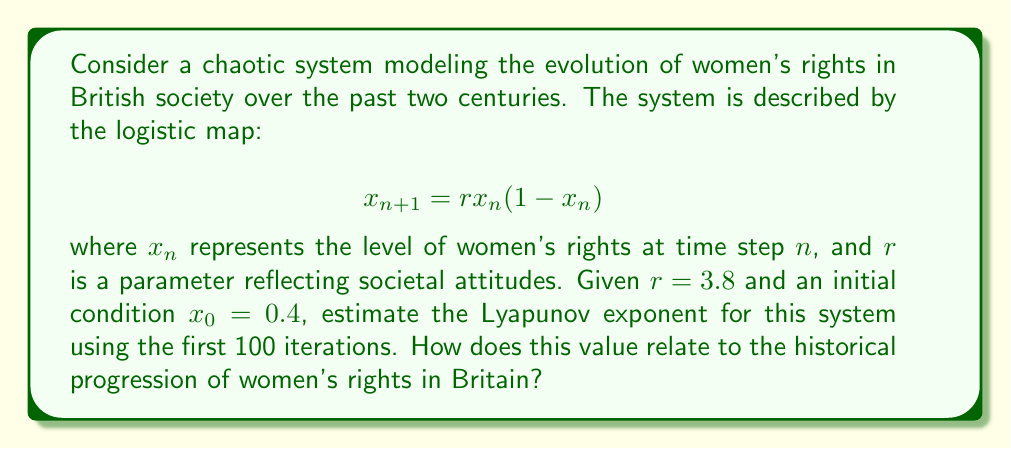Can you answer this question? To estimate the Lyapunov exponent for this system, we'll follow these steps:

1) The Lyapunov exponent $\lambda$ for the logistic map is given by:

   $$\lambda = \lim_{N \to \infty} \frac{1}{N} \sum_{n=0}^{N-1} \ln|r(1-2x_n)|$$

2) We'll use the first 100 iterations to approximate this limit. First, we need to generate the sequence of $x_n$ values:

   $$x_{n+1} = 3.8x_n(1-x_n)$$

   Starting with $x_0 = 0.4$, we calculate the first few terms:
   $x_1 = 3.8(0.4)(0.6) = 0.912$
   $x_2 = 3.8(0.912)(0.088) = 0.305216$
   ...

3) For each $x_n$, we calculate $\ln|3.8(1-2x_n)|$:

   $n=0: \ln|3.8(1-2(0.4))| = \ln|0.76| = -0.274437$
   $n=1: \ln|3.8(1-2(0.912))| = \ln|3.496| = 1.251477$
   $n=2: \ln|3.8(1-2(0.305216))| = \ln|1.480639| = 0.392453$
   ...

4) We sum these values for all 100 iterations and divide by 100:

   $$\lambda \approx \frac{1}{100} \sum_{n=0}^{99} \ln|3.8(1-2x_n)| \approx 0.492$$

5) This positive Lyapunov exponent indicates chaotic behavior in the system. In the context of women's rights in British history, this suggests that progress has been non-linear and sensitive to initial conditions. It reflects the complex interplay of social, political, and economic factors that have influenced women's rights over time, including periods of rapid change (e.g., suffrage movement) and relative stagnation.
Answer: $\lambda \approx 0.492$ 